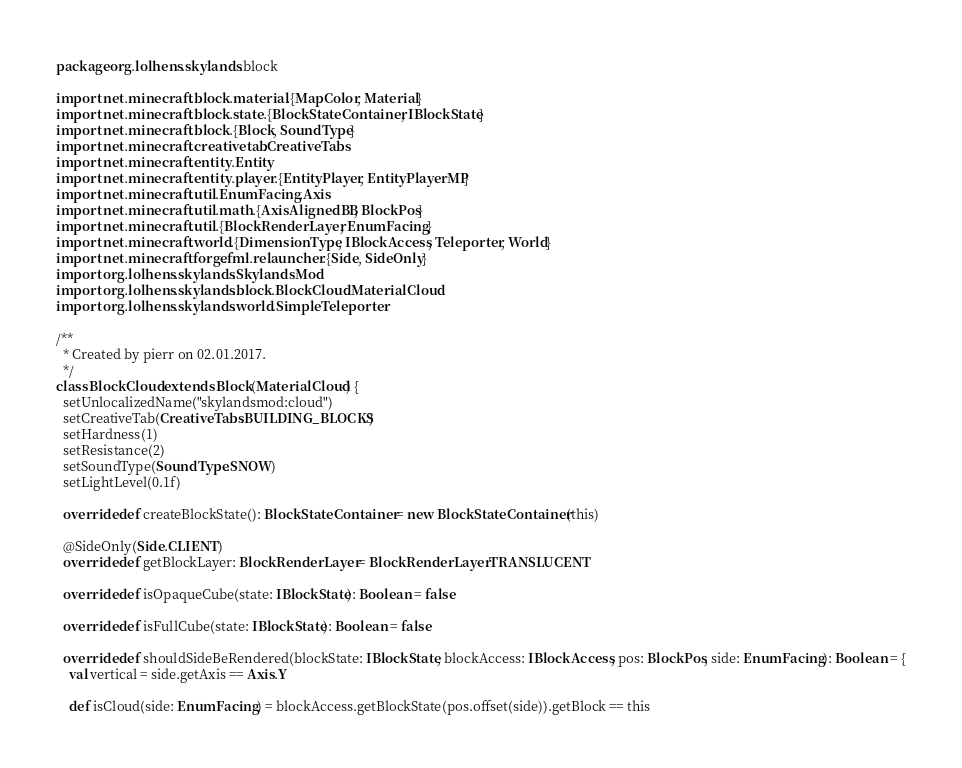<code> <loc_0><loc_0><loc_500><loc_500><_Scala_>package org.lolhens.skylands.block

import net.minecraft.block.material.{MapColor, Material}
import net.minecraft.block.state.{BlockStateContainer, IBlockState}
import net.minecraft.block.{Block, SoundType}
import net.minecraft.creativetab.CreativeTabs
import net.minecraft.entity.Entity
import net.minecraft.entity.player.{EntityPlayer, EntityPlayerMP}
import net.minecraft.util.EnumFacing.Axis
import net.minecraft.util.math.{AxisAlignedBB, BlockPos}
import net.minecraft.util.{BlockRenderLayer, EnumFacing}
import net.minecraft.world.{DimensionType, IBlockAccess, Teleporter, World}
import net.minecraftforge.fml.relauncher.{Side, SideOnly}
import org.lolhens.skylands.SkylandsMod
import org.lolhens.skylands.block.BlockCloud.MaterialCloud
import org.lolhens.skylands.world.SimpleTeleporter

/**
  * Created by pierr on 02.01.2017.
  */
class BlockCloud extends Block(MaterialCloud) {
  setUnlocalizedName("skylandsmod:cloud")
  setCreativeTab(CreativeTabs.BUILDING_BLOCKS)
  setHardness(1)
  setResistance(2)
  setSoundType(SoundType.SNOW)
  setLightLevel(0.1f)

  override def createBlockState(): BlockStateContainer = new BlockStateContainer(this)

  @SideOnly(Side.CLIENT)
  override def getBlockLayer: BlockRenderLayer = BlockRenderLayer.TRANSLUCENT

  override def isOpaqueCube(state: IBlockState): Boolean = false

  override def isFullCube(state: IBlockState): Boolean = false

  override def shouldSideBeRendered(blockState: IBlockState, blockAccess: IBlockAccess, pos: BlockPos, side: EnumFacing): Boolean = {
    val vertical = side.getAxis == Axis.Y

    def isCloud(side: EnumFacing) = blockAccess.getBlockState(pos.offset(side)).getBlock == this
</code> 